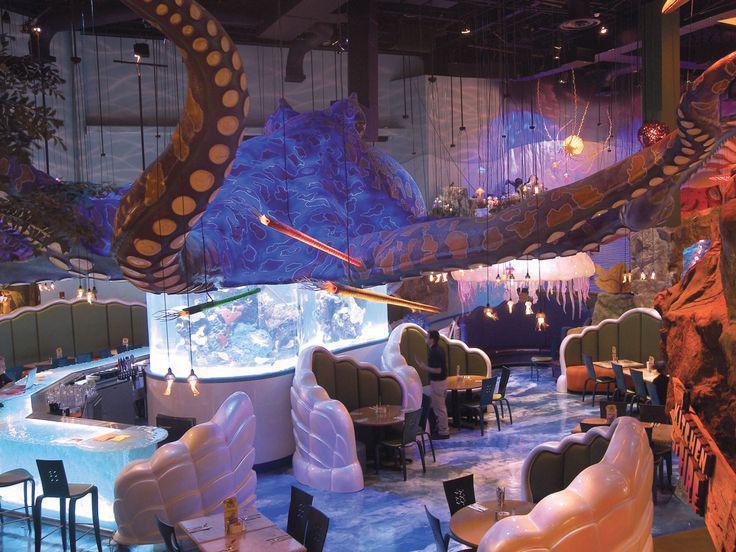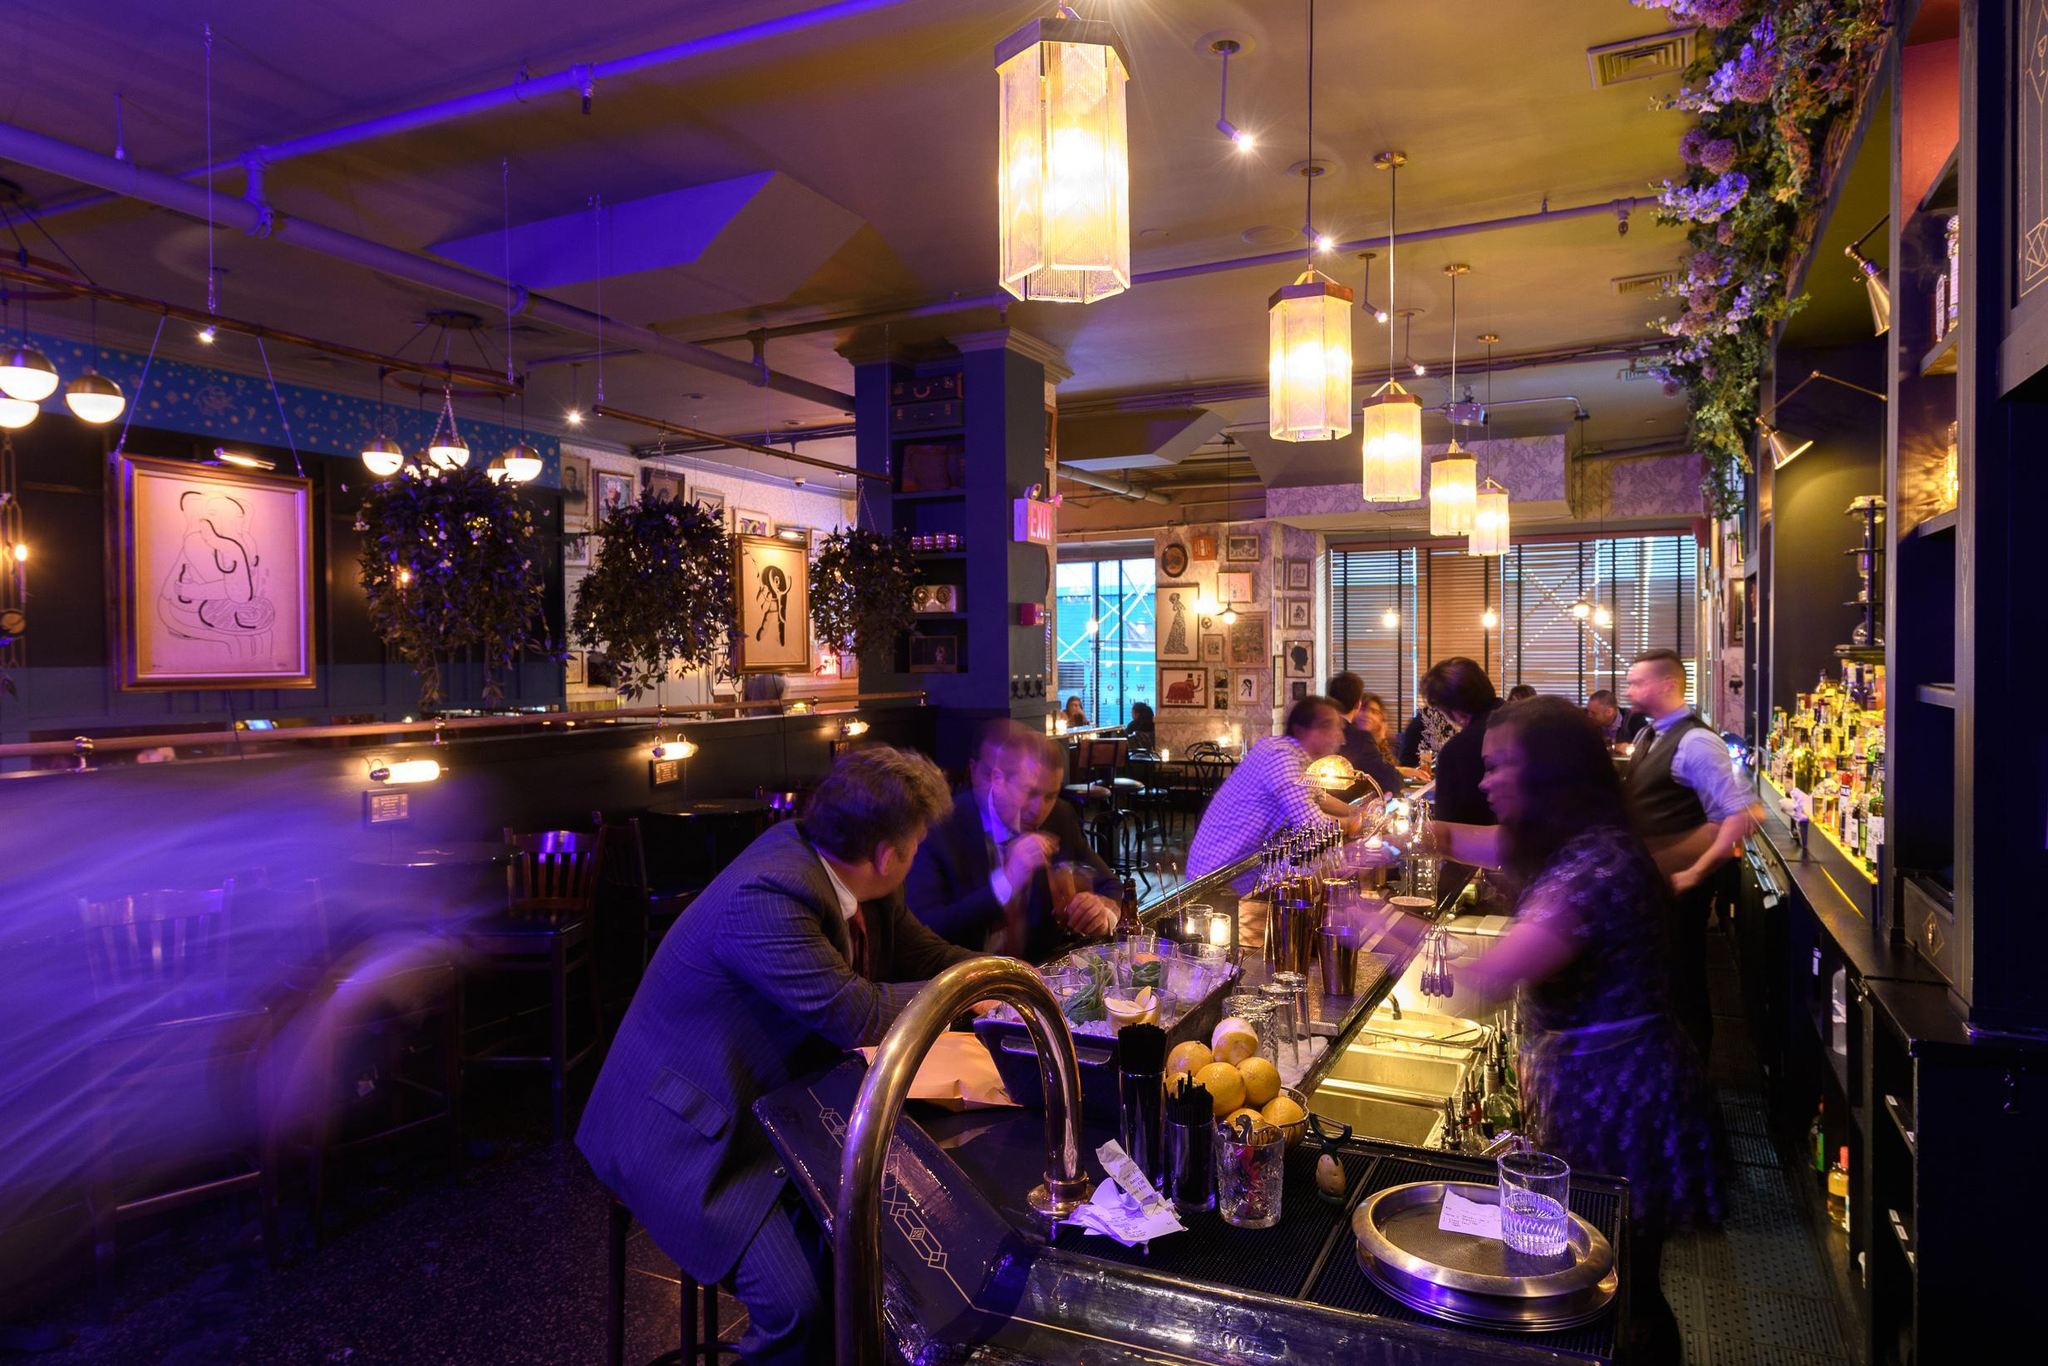The first image is the image on the left, the second image is the image on the right. Evaluate the accuracy of this statement regarding the images: "There are lights hanging from the ceiling in both images.". Is it true? Answer yes or no. No. The first image is the image on the left, the second image is the image on the right. For the images displayed, is the sentence "There are two empty cafes with no more than one person in the whole image." factually correct? Answer yes or no. No. 